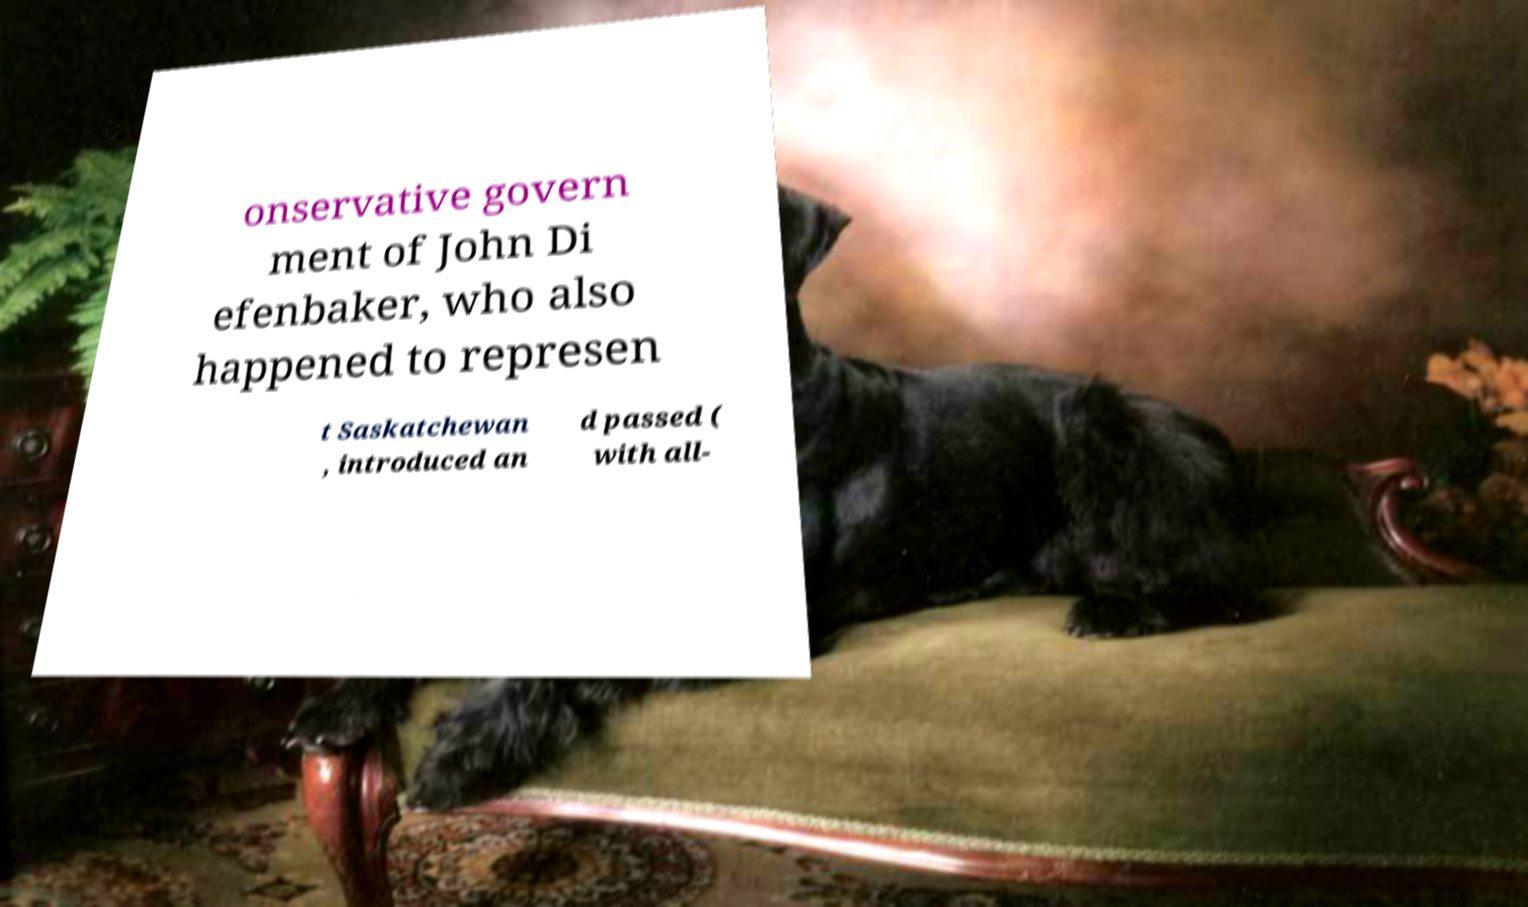Could you assist in decoding the text presented in this image and type it out clearly? onservative govern ment of John Di efenbaker, who also happened to represen t Saskatchewan , introduced an d passed ( with all- 